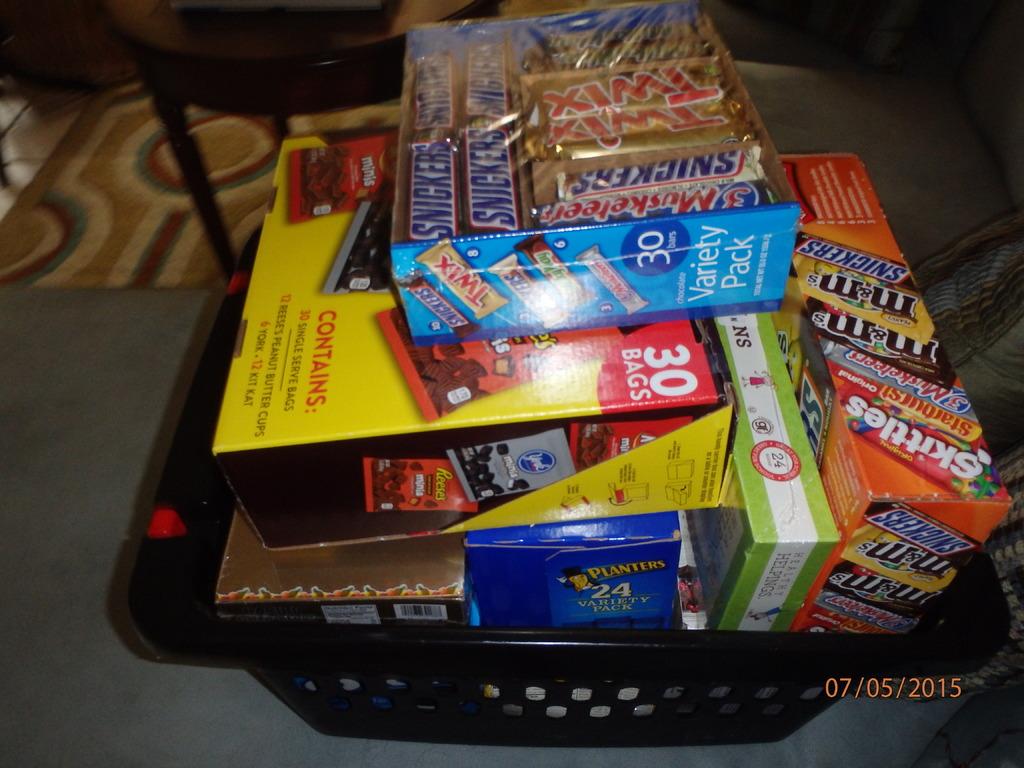How many bars are in the variety pack box?
Provide a succinct answer. 30. What brand of peanuts are in the blue box on the bottom?
Your answer should be compact. Planters. 